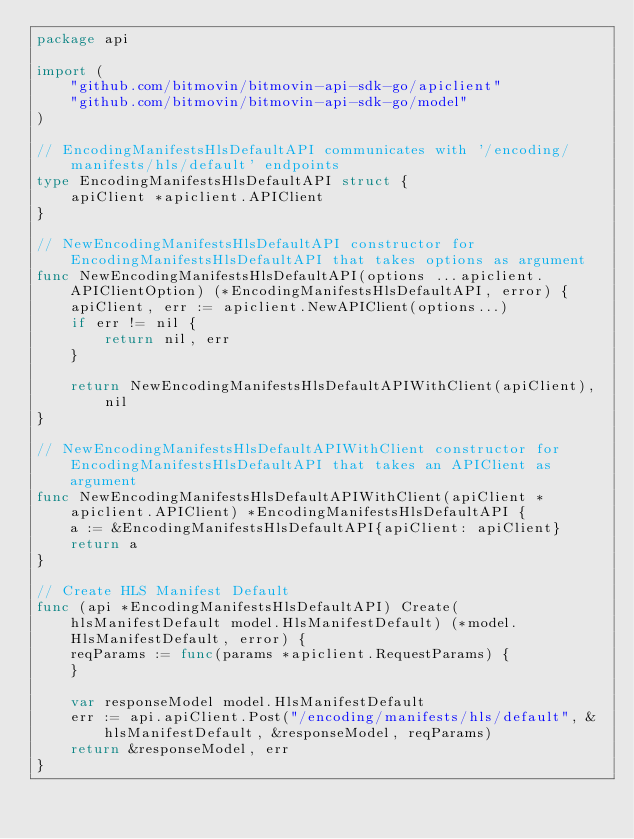Convert code to text. <code><loc_0><loc_0><loc_500><loc_500><_Go_>package api

import (
	"github.com/bitmovin/bitmovin-api-sdk-go/apiclient"
	"github.com/bitmovin/bitmovin-api-sdk-go/model"
)

// EncodingManifestsHlsDefaultAPI communicates with '/encoding/manifests/hls/default' endpoints
type EncodingManifestsHlsDefaultAPI struct {
	apiClient *apiclient.APIClient
}

// NewEncodingManifestsHlsDefaultAPI constructor for EncodingManifestsHlsDefaultAPI that takes options as argument
func NewEncodingManifestsHlsDefaultAPI(options ...apiclient.APIClientOption) (*EncodingManifestsHlsDefaultAPI, error) {
	apiClient, err := apiclient.NewAPIClient(options...)
	if err != nil {
		return nil, err
	}

	return NewEncodingManifestsHlsDefaultAPIWithClient(apiClient), nil
}

// NewEncodingManifestsHlsDefaultAPIWithClient constructor for EncodingManifestsHlsDefaultAPI that takes an APIClient as argument
func NewEncodingManifestsHlsDefaultAPIWithClient(apiClient *apiclient.APIClient) *EncodingManifestsHlsDefaultAPI {
	a := &EncodingManifestsHlsDefaultAPI{apiClient: apiClient}
	return a
}

// Create HLS Manifest Default
func (api *EncodingManifestsHlsDefaultAPI) Create(hlsManifestDefault model.HlsManifestDefault) (*model.HlsManifestDefault, error) {
	reqParams := func(params *apiclient.RequestParams) {
	}

	var responseModel model.HlsManifestDefault
	err := api.apiClient.Post("/encoding/manifests/hls/default", &hlsManifestDefault, &responseModel, reqParams)
	return &responseModel, err
}
</code> 